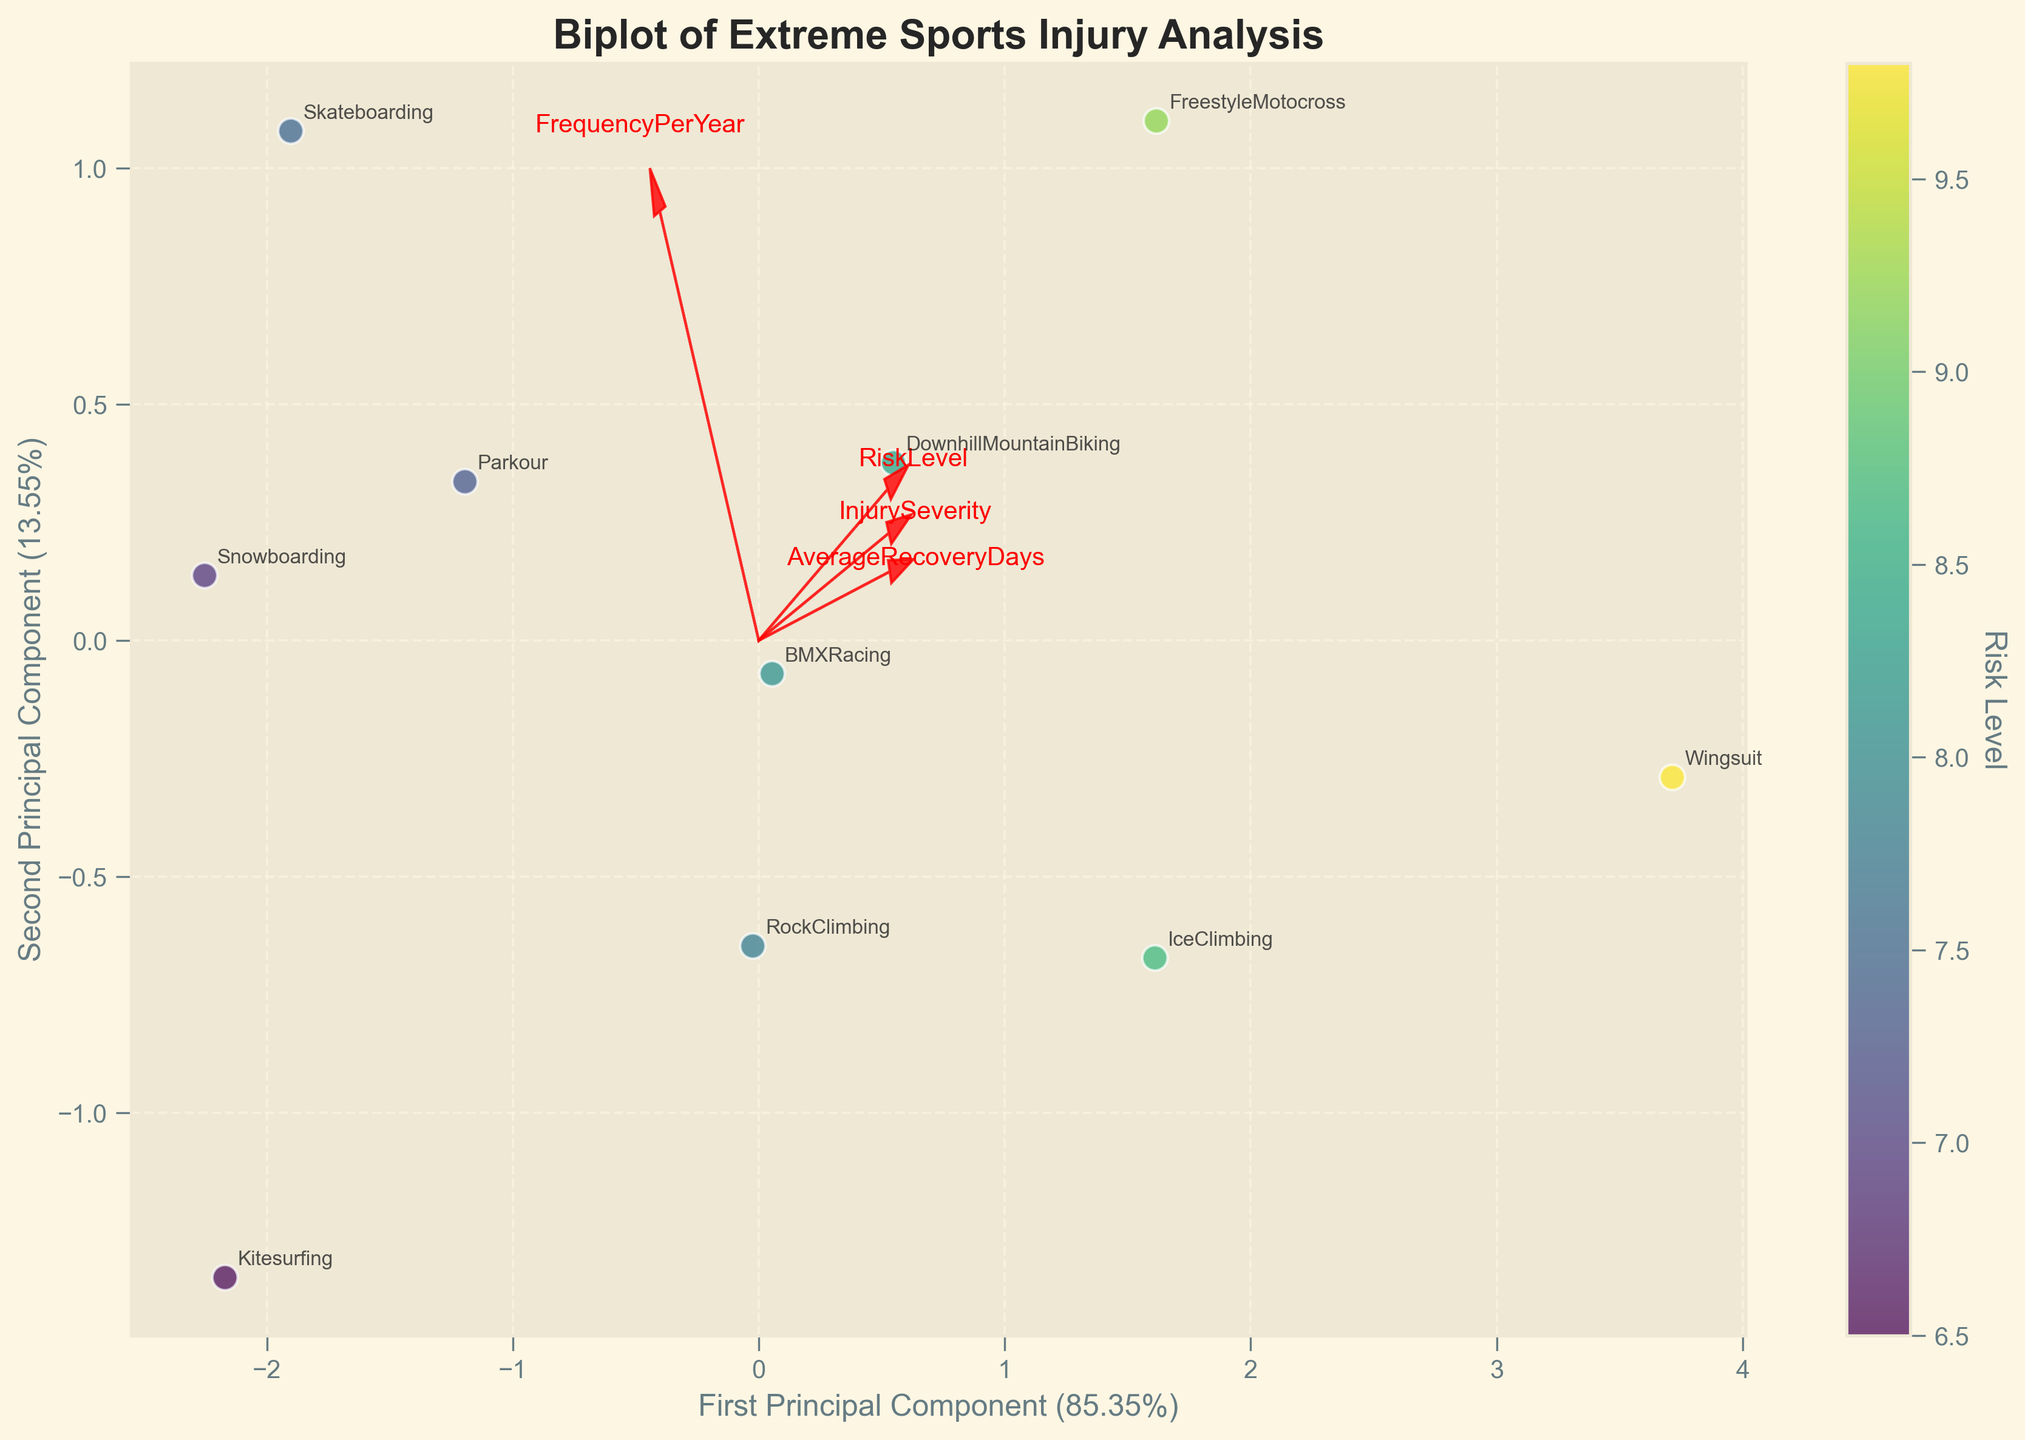What's the title of the biplot? The title of the biplot is mentioned at the top of the figure, which describes the purpose or content of the plot.
Answer: Biplot of Extreme Sports Injury Analysis How many data points are plotted? Look at each distinct point representing a different discipline on the biplot. Each point corresponds to a row in the dataset.
Answer: 10 Which extreme sport has the highest Risk Level? The color intensity on the biplot indicates the Risk Level. The discipline with the most intense color represents the highest risk level.
Answer: Wingsuit Which feature vectors point towards high Injury Severity and Frequency Per Year directions? Feature vectors in the biplot are arrows. Identify which arrows extend furthest to the higher values of Injury Severity and Frequency Per Year on their respective axes.
Answer: InjurySeverity and FrequencyPerYear What are the first two principal components in percentage? The x and y axis labels give the explained variance in percentage for the first two principal components.
Answer: First: ~43.75%, Second: ~31.93% Which extreme sports have Injury Severity and Risk Level vectors pointing in approximately the same direction? Look for the direction of the Injury Severity and Risk Level vectors and see which sports' points are aligned similarly.
Answer: Freestyle Motocross, Wingsuit, IceClimbing What's the sum of the explained variances of the first two principal components? Add the percentages given by the x and y axis labels representing the variance explained by each principal component.
Answer: ~75.68% Do any sports have similar principal component scores but differ greatly in Risk Level? Identify close points in the biplot along the principal components while observing their color differences to note varying Risk Levels.
Answer: Snowboarding and Skateboarding Which sport is closest to the origin in the biplot? The data point positioned nearest to the (0,0) coordinate on the biplot.
Answer: Snowboarding Which features have the arrows almost perpendicular to each other indicating less correlation? Examine the feature vectors (arrows). Perpendicular arrows suggest low or no correlation between those features.
Answer: AverageRecoveryDays and FrequencyPerYear 